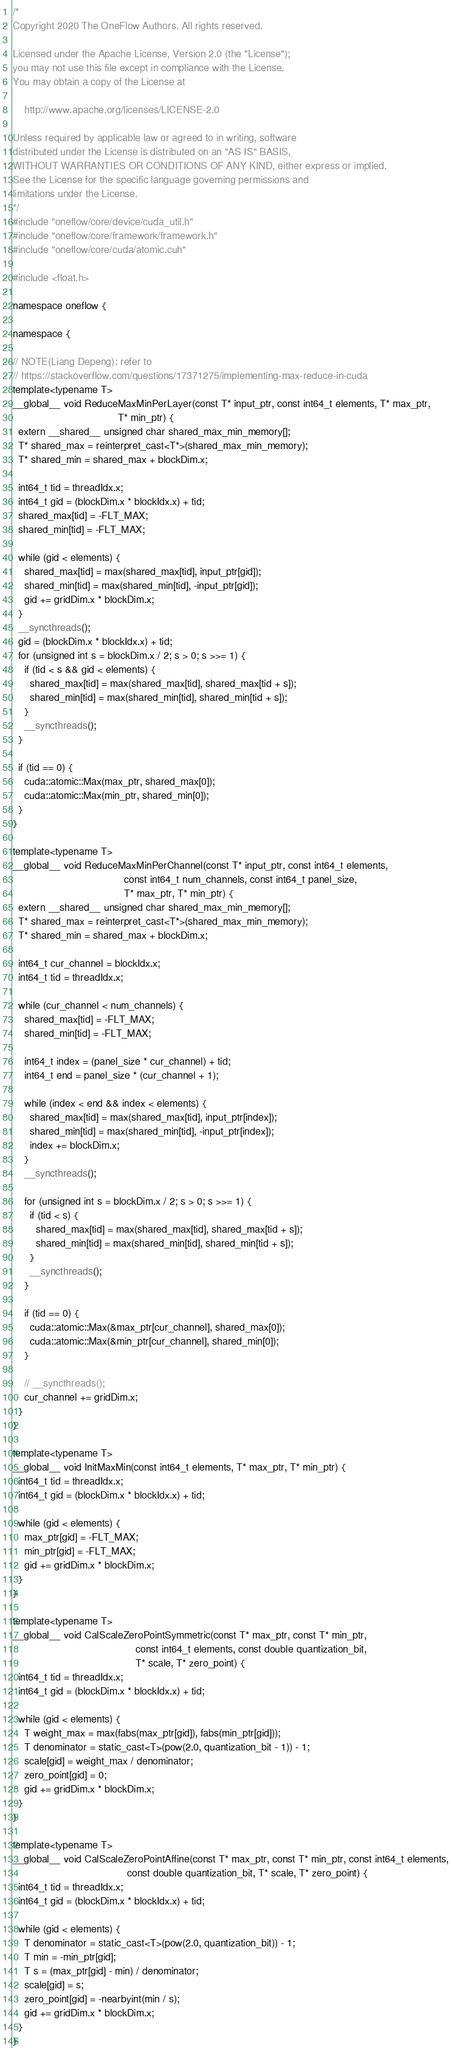Convert code to text. <code><loc_0><loc_0><loc_500><loc_500><_Cuda_>/*
Copyright 2020 The OneFlow Authors. All rights reserved.

Licensed under the Apache License, Version 2.0 (the "License");
you may not use this file except in compliance with the License.
You may obtain a copy of the License at

    http://www.apache.org/licenses/LICENSE-2.0

Unless required by applicable law or agreed to in writing, software
distributed under the License is distributed on an "AS IS" BASIS,
WITHOUT WARRANTIES OR CONDITIONS OF ANY KIND, either express or implied.
See the License for the specific language governing permissions and
limitations under the License.
*/
#include "oneflow/core/device/cuda_util.h"
#include "oneflow/core/framework/framework.h"
#include "oneflow/core/cuda/atomic.cuh"

#include <float.h>

namespace oneflow {

namespace {

// NOTE(Liang Depeng): refer to
// https://stackoverflow.com/questions/17371275/implementing-max-reduce-in-cuda
template<typename T>
__global__ void ReduceMaxMinPerLayer(const T* input_ptr, const int64_t elements, T* max_ptr,
                                     T* min_ptr) {
  extern __shared__ unsigned char shared_max_min_memory[];
  T* shared_max = reinterpret_cast<T*>(shared_max_min_memory);
  T* shared_min = shared_max + blockDim.x;

  int64_t tid = threadIdx.x;
  int64_t gid = (blockDim.x * blockIdx.x) + tid;
  shared_max[tid] = -FLT_MAX;
  shared_min[tid] = -FLT_MAX;

  while (gid < elements) {
    shared_max[tid] = max(shared_max[tid], input_ptr[gid]);
    shared_min[tid] = max(shared_min[tid], -input_ptr[gid]);
    gid += gridDim.x * blockDim.x;
  }
  __syncthreads();
  gid = (blockDim.x * blockIdx.x) + tid;
  for (unsigned int s = blockDim.x / 2; s > 0; s >>= 1) {
    if (tid < s && gid < elements) {
      shared_max[tid] = max(shared_max[tid], shared_max[tid + s]);
      shared_min[tid] = max(shared_min[tid], shared_min[tid + s]);
    }
    __syncthreads();
  }

  if (tid == 0) {
    cuda::atomic::Max(max_ptr, shared_max[0]);
    cuda::atomic::Max(min_ptr, shared_min[0]);
  }
}

template<typename T>
__global__ void ReduceMaxMinPerChannel(const T* input_ptr, const int64_t elements,
                                       const int64_t num_channels, const int64_t panel_size,
                                       T* max_ptr, T* min_ptr) {
  extern __shared__ unsigned char shared_max_min_memory[];
  T* shared_max = reinterpret_cast<T*>(shared_max_min_memory);
  T* shared_min = shared_max + blockDim.x;

  int64_t cur_channel = blockIdx.x;
  int64_t tid = threadIdx.x;

  while (cur_channel < num_channels) {
    shared_max[tid] = -FLT_MAX;
    shared_min[tid] = -FLT_MAX;

    int64_t index = (panel_size * cur_channel) + tid;
    int64_t end = panel_size * (cur_channel + 1);

    while (index < end && index < elements) {
      shared_max[tid] = max(shared_max[tid], input_ptr[index]);
      shared_min[tid] = max(shared_min[tid], -input_ptr[index]);
      index += blockDim.x;
    }
    __syncthreads();

    for (unsigned int s = blockDim.x / 2; s > 0; s >>= 1) {
      if (tid < s) {
        shared_max[tid] = max(shared_max[tid], shared_max[tid + s]);
        shared_min[tid] = max(shared_min[tid], shared_min[tid + s]);
      }
      __syncthreads();
    }

    if (tid == 0) {
      cuda::atomic::Max(&max_ptr[cur_channel], shared_max[0]);
      cuda::atomic::Max(&min_ptr[cur_channel], shared_min[0]);
    }

    // __syncthreads();
    cur_channel += gridDim.x;
  }
}

template<typename T>
__global__ void InitMaxMin(const int64_t elements, T* max_ptr, T* min_ptr) {
  int64_t tid = threadIdx.x;
  int64_t gid = (blockDim.x * blockIdx.x) + tid;

  while (gid < elements) {
    max_ptr[gid] = -FLT_MAX;
    min_ptr[gid] = -FLT_MAX;
    gid += gridDim.x * blockDim.x;
  }
}

template<typename T>
__global__ void CalScaleZeroPointSymmetric(const T* max_ptr, const T* min_ptr,
                                           const int64_t elements, const double quantization_bit,
                                           T* scale, T* zero_point) {
  int64_t tid = threadIdx.x;
  int64_t gid = (blockDim.x * blockIdx.x) + tid;

  while (gid < elements) {
    T weight_max = max(fabs(max_ptr[gid]), fabs(min_ptr[gid]));
    T denominator = static_cast<T>(pow(2.0, quantization_bit - 1)) - 1;
    scale[gid] = weight_max / denominator;
    zero_point[gid] = 0;
    gid += gridDim.x * blockDim.x;
  }
}

template<typename T>
__global__ void CalScaleZeroPointAffine(const T* max_ptr, const T* min_ptr, const int64_t elements,
                                        const double quantization_bit, T* scale, T* zero_point) {
  int64_t tid = threadIdx.x;
  int64_t gid = (blockDim.x * blockIdx.x) + tid;

  while (gid < elements) {
    T denominator = static_cast<T>(pow(2.0, quantization_bit)) - 1;
    T min = -min_ptr[gid];
    T s = (max_ptr[gid] - min) / denominator;
    scale[gid] = s;
    zero_point[gid] = -nearbyint(min / s);
    gid += gridDim.x * blockDim.x;
  }
}
</code> 